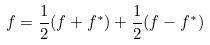<formula> <loc_0><loc_0><loc_500><loc_500>f = \frac { 1 } { 2 } ( f + f ^ { * } ) + \frac { 1 } { 2 } ( f - f ^ { * } )</formula> 